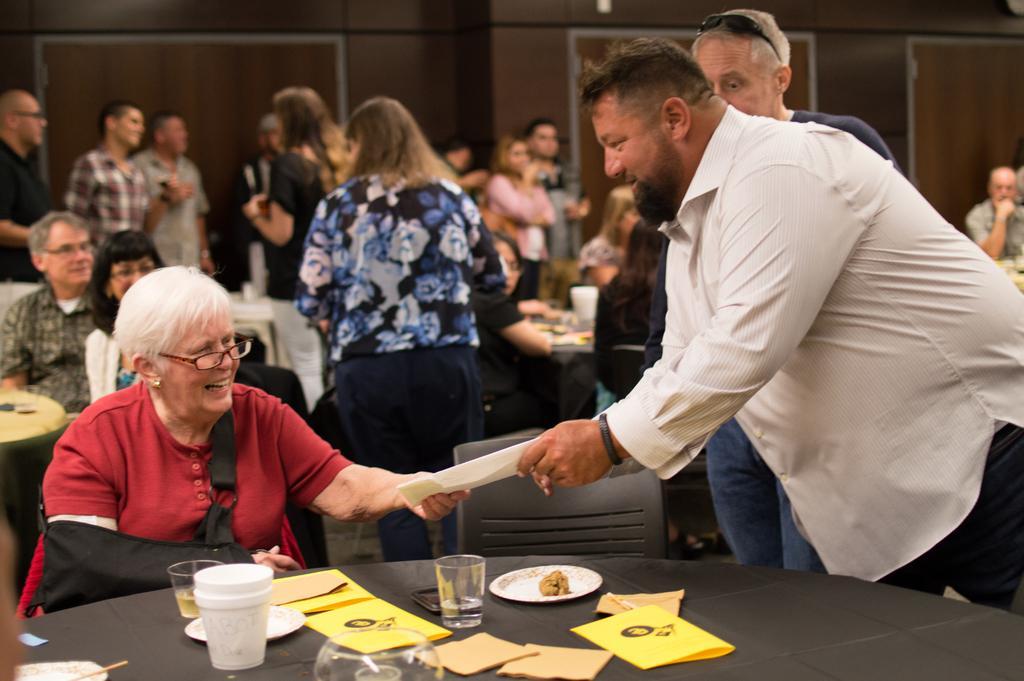In one or two sentences, can you explain what this image depicts? In this image, There is a table which is in black color on that table there are some glasses and there are some plants which are in white color, There are some papers in yellow color, In the left side there is a woman sitting and she is receiving a paper from a man which is in white color, In the right side there are some people standing and in the background there are some people sitting on the chairs and there is a black color wall. 